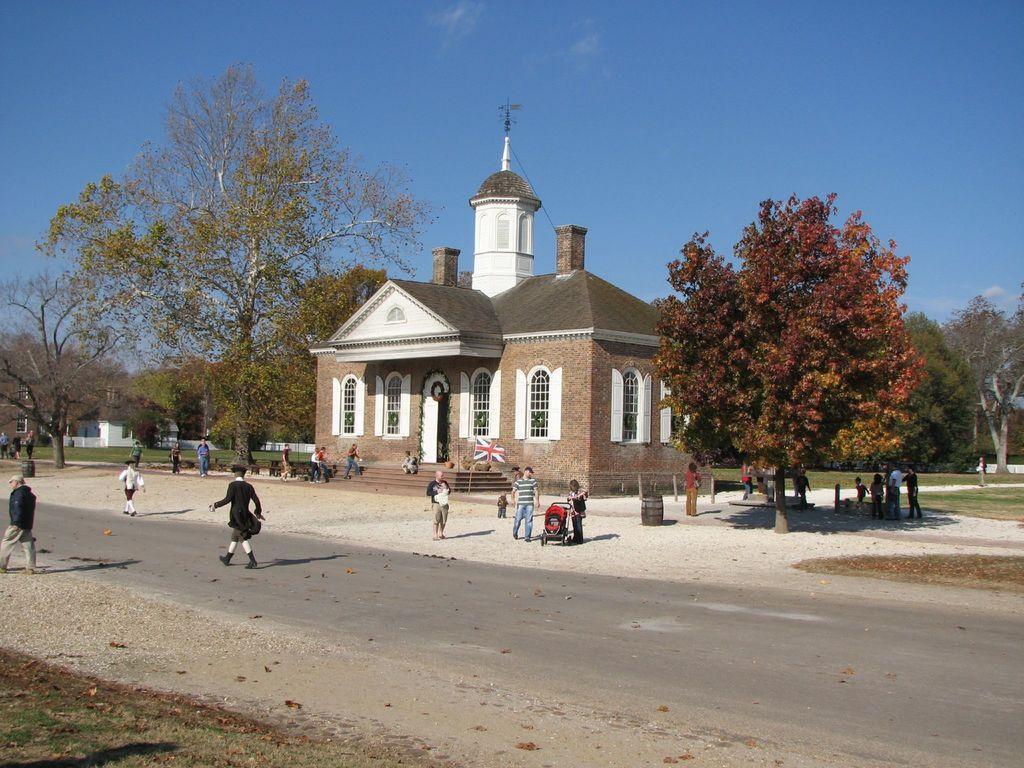Could you give a brief overview of what you see in this image? In this picture I can see in the middle few people are there, in the middle there is a flag and a building. There are trees on either side of this image, at the top there is the sky. 